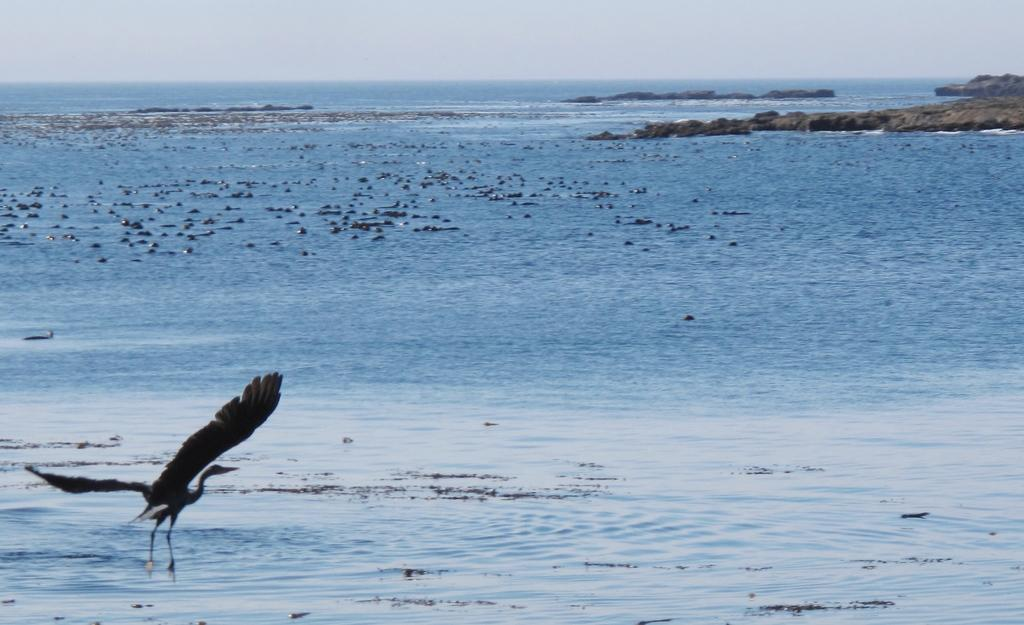What is the main subject of the image? The main subject of the image is a bird flying. What can be seen in the background of the image? There is water and the sky visible in the image. What type of objects are present in the image? There are stones in the image. Where can the honey be found in the image? There is no honey present in the image. What season is depicted in the image? The provided facts do not specify a season, so it cannot be determined from the image. 